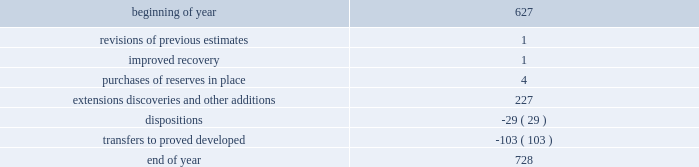During 2014 , 2013 and 2012 , netherland , sewell & associates , inc .
( "nsai" ) prepared a certification of the prior year's reserves for the alba field in e.g .
The nsai summary reports are filed as an exhibit to this annual report on form 10-k .
Members of the nsai team have multiple years of industry experience , having worked for large , international oil and gas companies before joining nsai .
The senior technical advisor has over 35 years of practical experience in petroleum geosciences , with over 15 years experience in the estimation and evaluation of reserves .
The second team member has over 10 years of practical experience in petroleum engineering , with 5 years experience in the estimation and evaluation of reserves .
Both are registered professional engineers in the state of texas .
Ryder scott company ( "ryder scott" ) also performed audits of the prior years' reserves of several of our fields in 2014 , 2013 and 2012 .
Their summary reports are filed as exhibits to this annual report on form 10-k .
The team lead for ryder scott has over 20 years of industry experience , having worked for a major international oil and gas company before joining ryder scott .
He is a member of spe , where he served on the oil and gas reserves committee , and is a registered professional engineer in the state of texas .
Changes in proved undeveloped reserves as of december 31 , 2014 , 728 mmboe of proved undeveloped reserves were reported , an increase of 101 mmboe from december 31 , 2013 .
The table shows changes in total proved undeveloped reserves for 2014 : ( mmboe ) .
Significant additions to proved undeveloped reserves during 2014 included 121 mmboe in the eagle ford and 61 mmboe in the bakken shale plays due to development drilling .
Transfers from proved undeveloped to proved developed reserves included 67 mmboe in the eagle ford , 26 mmboe in the bakken and 1 mmboe in the oklahoma resource basins due to development drilling and completions .
Costs incurred in 2014 , 2013 and 2012 relating to the development of proved undeveloped reserves , were $ 3149 million , $ 2536 million and $ 1995 million .
A total of 102 mmboe was booked as extensions , discoveries or other additions due to the application of reliable technology .
Technologies included statistical analysis of production performance , decline curve analysis , pressure and rate transient analysis , reservoir simulation and volumetric analysis .
The statistical nature of production performance coupled with highly certain reservoir continuity or quality within the reliable technology areas and sufficient proved undeveloped locations establish the reasonable certainty criteria required for booking proved reserves .
Projects can remain in proved undeveloped reserves for extended periods in certain situations such as large development projects which take more than five years to complete , or the timing of when additional gas compression is needed .
Of the 728 mmboe of proved undeveloped reserves at december 31 , 2014 , 19 percent of the volume is associated with projects that have been included in proved reserves for more than five years .
The majority of this volume is related to a compression project in e.g .
That was sanctioned by our board of directors in 2004 .
The timing of the installation of compression is being driven by the reservoir performance with this project intended to maintain maximum production levels .
Performance of this field since the board sanctioned the project has far exceeded expectations .
Estimates of initial dry gas in place increased by roughly 10 percent between 2004 and 2010 .
During 2012 , the compression project received the approval of the e.g .
Government , allowing design and planning work to progress towards implementation , with completion expected by mid-2016 .
The other component of alba proved undeveloped reserves is an infill well approved in 2013 and to be drilled in the second quarter of 2015 .
Proved undeveloped reserves for the north gialo development , located in the libyan sahara desert , were booked for the first time in 2010 .
This development , which is anticipated to take more than five years to develop , is executed by the operator and encompasses a multi-year drilling program including the design , fabrication and installation of extensive liquid handling and gas recycling facilities .
Anecdotal evidence from similar development projects in the region lead to an expected project execution time frame of more than five years from the time the reserves were initially booked .
Interruptions associated with the civil unrest in 2011 and third-party labor strikes and civil unrest in 2013-2014 have also extended the project duration .
As of december 31 , 2014 , future development costs estimated to be required for the development of proved undeveloped crude oil and condensate , ngls , natural gas and synthetic crude oil reserves related to continuing operations for the years 2015 through 2019 are projected to be $ 2915 million , $ 2598 million , $ 2493 million , $ 2669 million and $ 2745 million. .
By how much did undeveloped reserves increase throughout 2014 ff1f? 
Computations: ((728 - 627) / 728)
Answer: 0.13874. 